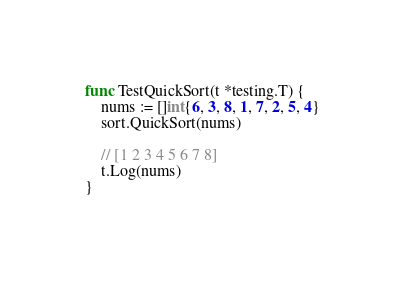<code> <loc_0><loc_0><loc_500><loc_500><_Go_>
func TestQuickSort(t *testing.T) {
	nums := []int{6, 3, 8, 1, 7, 2, 5, 4}
	sort.QuickSort(nums)

	// [1 2 3 4 5 6 7 8]
	t.Log(nums)
}
</code> 